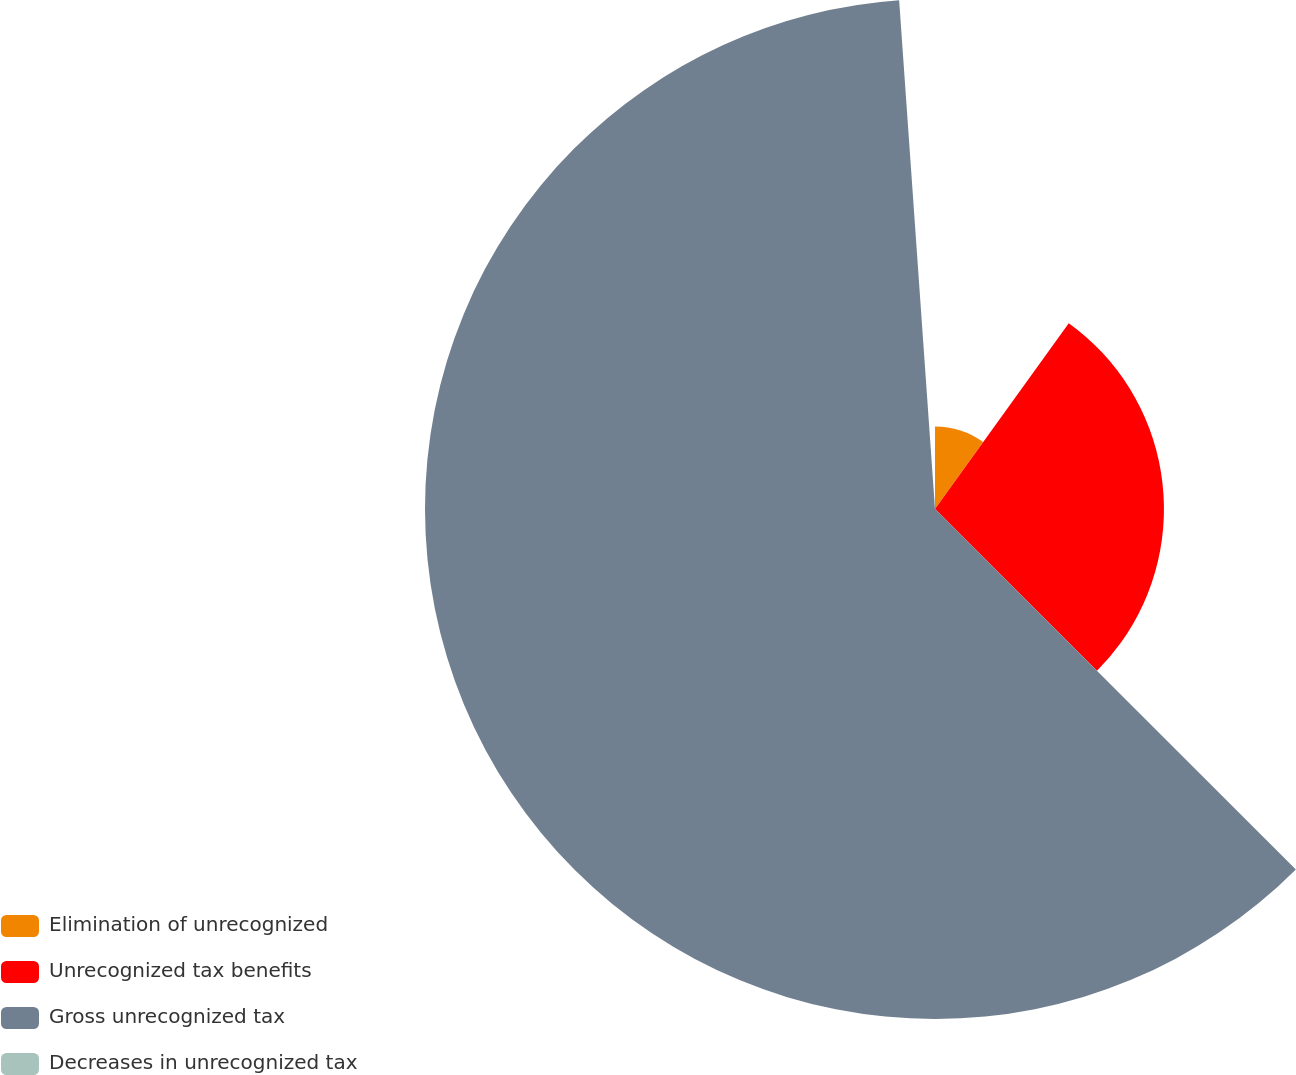<chart> <loc_0><loc_0><loc_500><loc_500><pie_chart><fcel>Elimination of unrecognized<fcel>Unrecognized tax benefits<fcel>Gross unrecognized tax<fcel>Decreases in unrecognized tax<nl><fcel>9.93%<fcel>27.56%<fcel>61.39%<fcel>1.12%<nl></chart> 